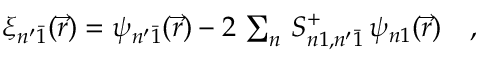<formula> <loc_0><loc_0><loc_500><loc_500>\begin{array} { r } { \xi _ { n ^ { \prime } \bar { 1 } } ( \vec { r } ) = \psi _ { n ^ { \prime } \bar { 1 } } ( \vec { r } ) - 2 \, \sum _ { n } \, S _ { n 1 , n ^ { \prime } \bar { 1 } } ^ { + } \, \psi _ { n 1 } ( \vec { r } ) \quad , } \end{array}</formula> 